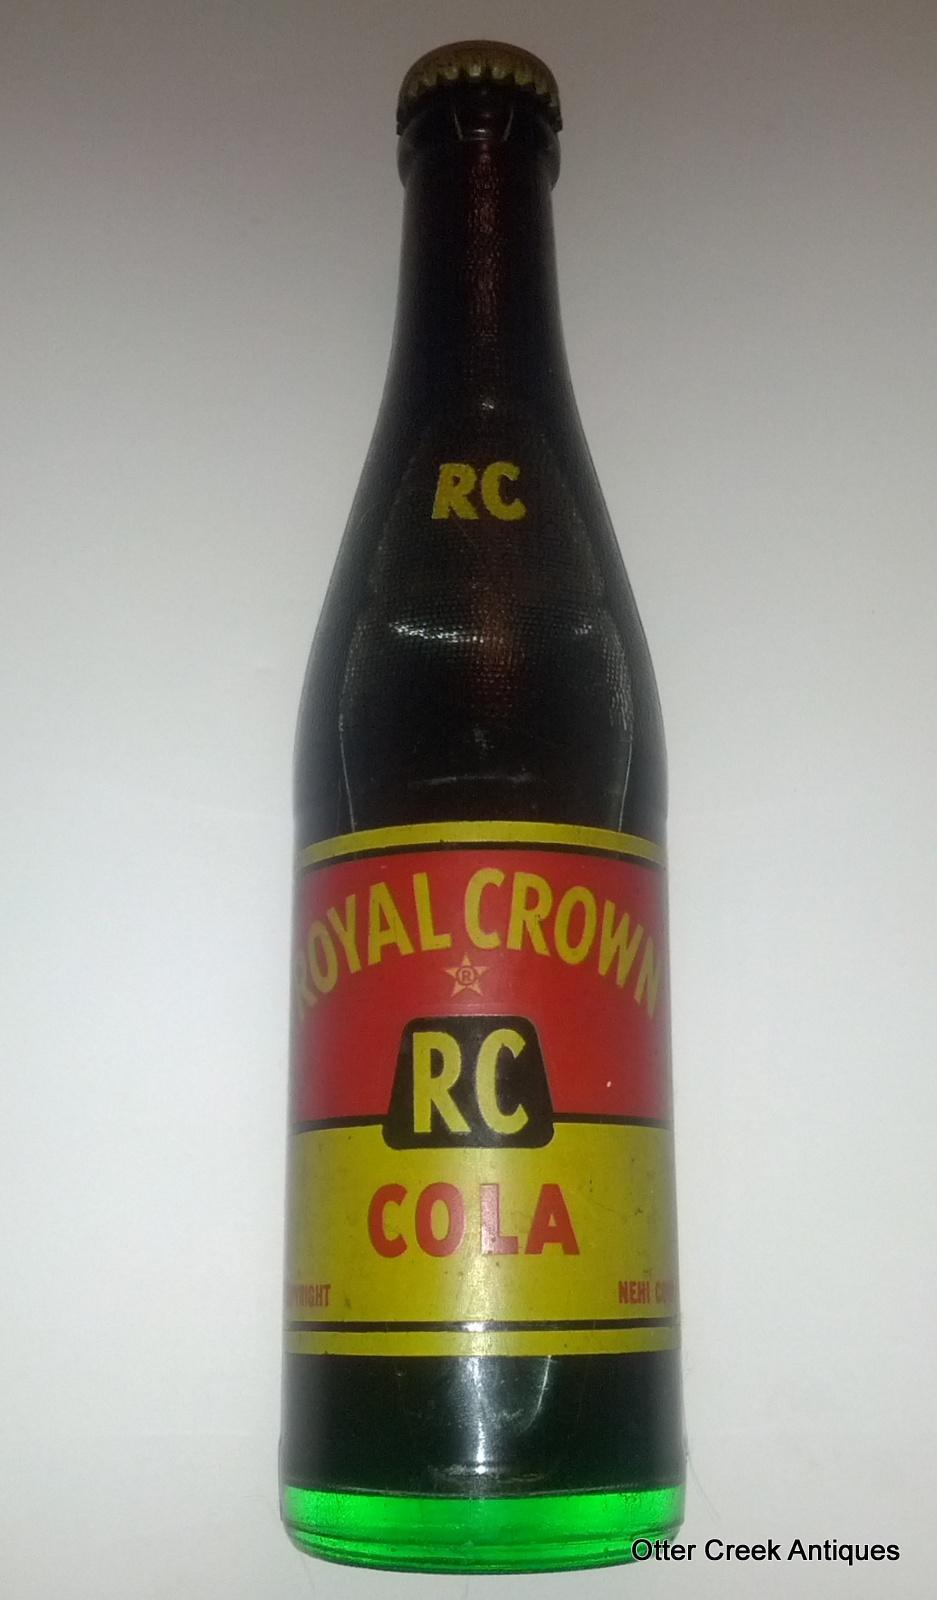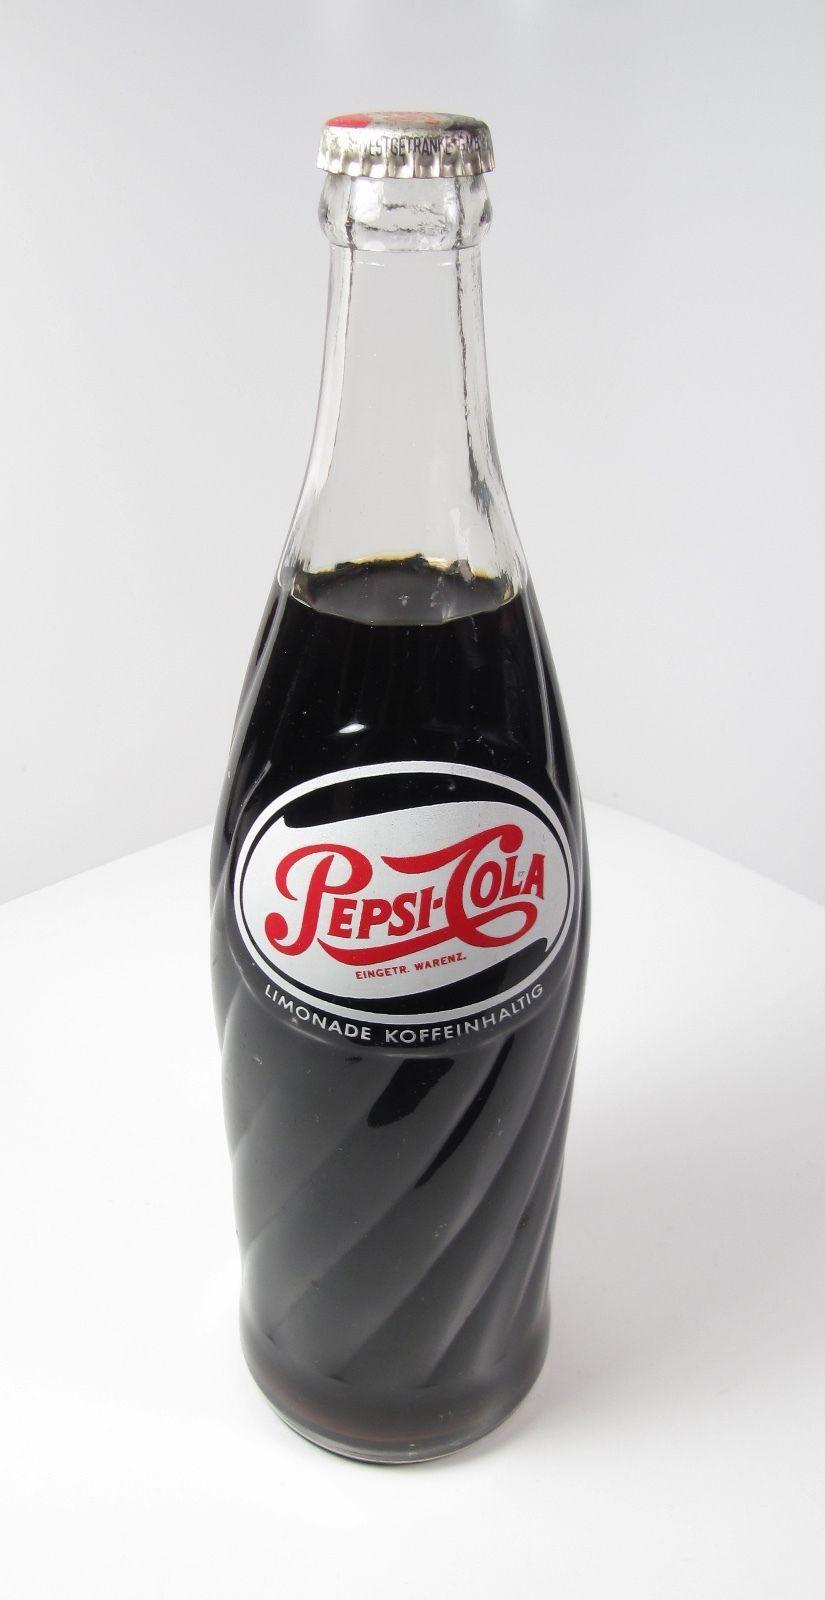The first image is the image on the left, the second image is the image on the right. Examine the images to the left and right. Is the description "At least one soda bottle is written in a foreign language." accurate? Answer yes or no. No. The first image is the image on the left, the second image is the image on the right. Evaluate the accuracy of this statement regarding the images: "The bottle in the left image has a partly red label.". Is it true? Answer yes or no. Yes. 